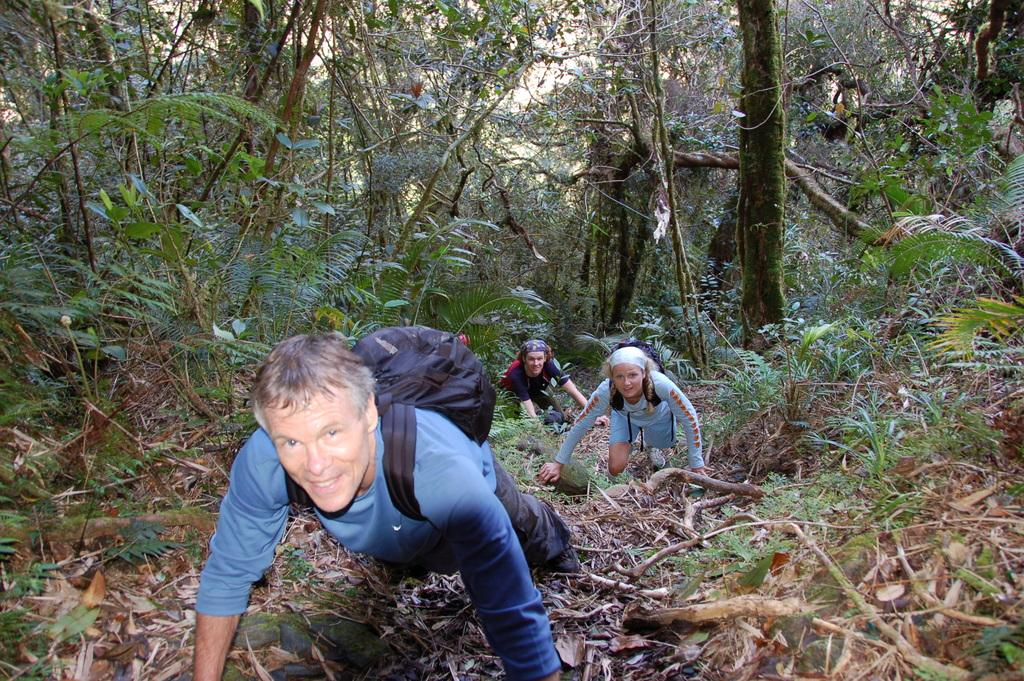Who or what is present in the image? There are people in the image. What are the people wearing? The people are wearing bags. What type of natural elements can be seen in the image? There are trees and plants in the image. Can you see a bear swimming in the image? No, there is no bear or swimming activity depicted in the image. 